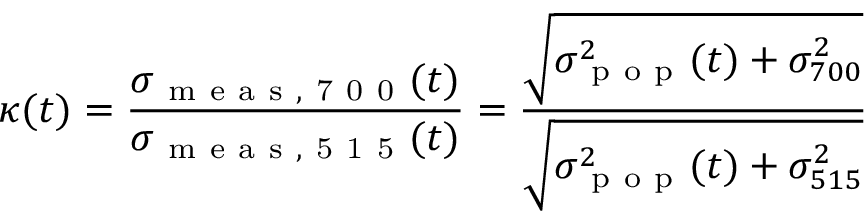<formula> <loc_0><loc_0><loc_500><loc_500>\kappa ( t ) = \frac { \sigma _ { m e a s , 7 0 0 } ( t ) } { \sigma _ { m e a s , 5 1 5 } ( t ) } = \frac { \sqrt { \sigma _ { p o p } ^ { 2 } ( t ) + \sigma _ { 7 0 0 } ^ { 2 } } } { \sqrt { \sigma _ { p o p } ^ { 2 } ( t ) + \sigma _ { 5 1 5 } ^ { 2 } } }</formula> 